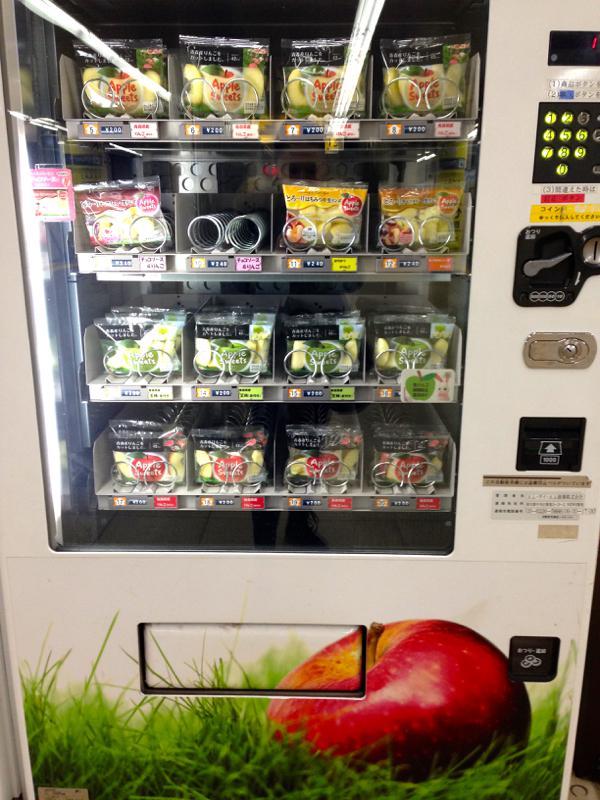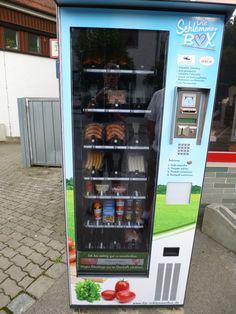The first image is the image on the left, the second image is the image on the right. Evaluate the accuracy of this statement regarding the images: "There are at least three vending machines that have food or drinks.". Is it true? Answer yes or no. No. 